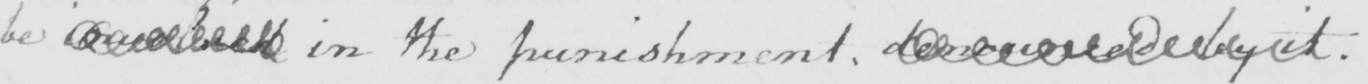Please transcribe the handwritten text in this image. be  <gap/>  in the punishment . denounced by it . 